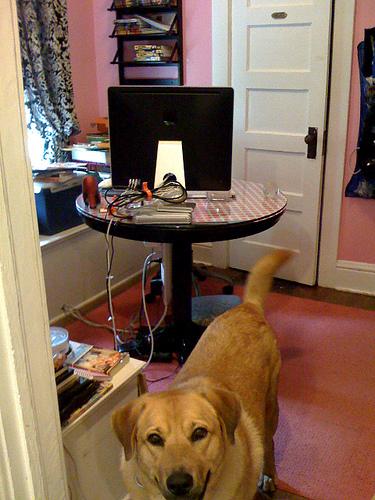Does the dog really love this ball?
Quick response, please. Yes. Is this dog on a floor?
Give a very brief answer. Yes. What color are the walls?
Answer briefly. Pink. Is the dog happy?
Quick response, please. Yes. What breed of dog is shown?
Answer briefly. Golden retriever. Is the bed messy or tidy?
Quick response, please. Messy. What kind of dog is this?
Concise answer only. Lab. Who is a good dog?
Keep it brief. Dog. Is this someone's workspace at the office?
Short answer required. No. Can the dog's tail be seen?
Concise answer only. Yes. Is this dog's tail wagging?
Concise answer only. Yes. Is the book open?
Give a very brief answer. No. 